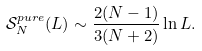<formula> <loc_0><loc_0><loc_500><loc_500>\mathcal { S } ^ { p u r e } _ { N } ( L ) \sim \frac { 2 ( N - 1 ) } { 3 ( N + 2 ) } \ln L .</formula> 